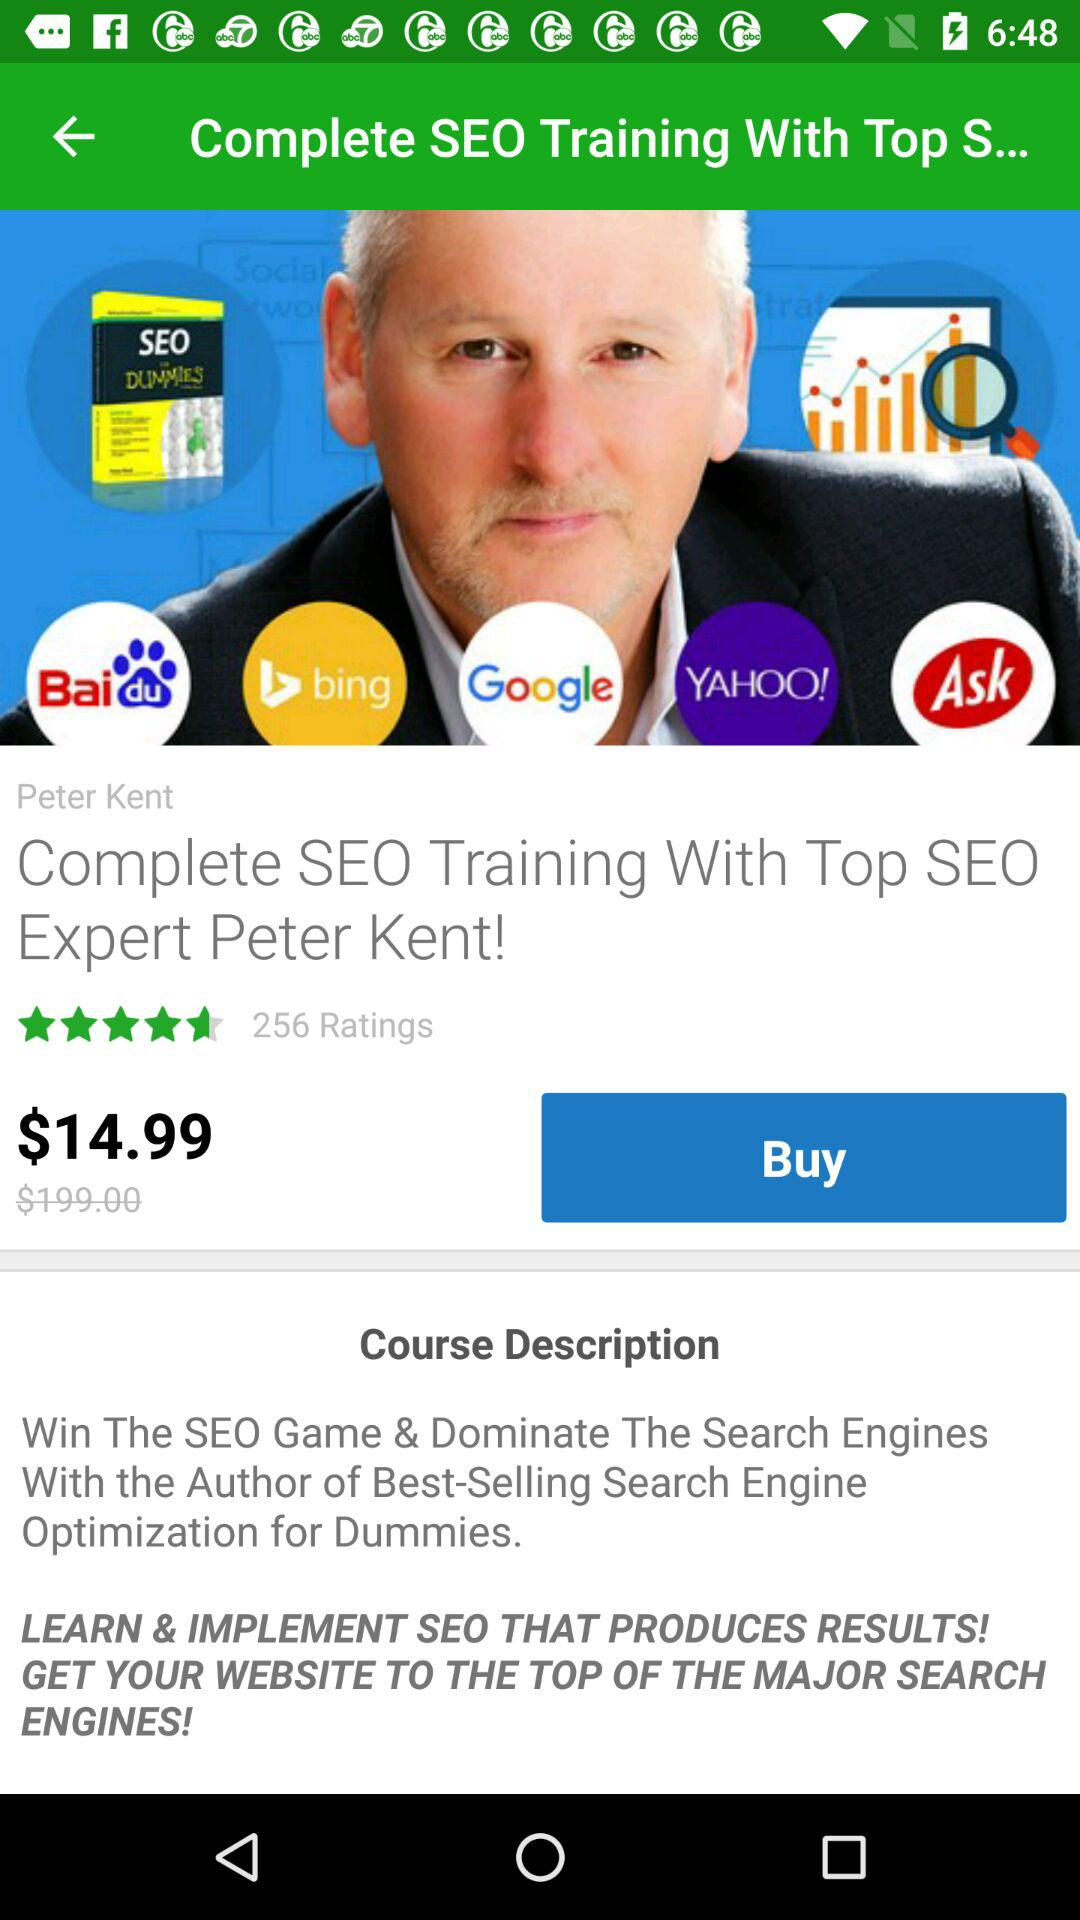Who is the trainer of the course? The trainer is Peter Kent. 